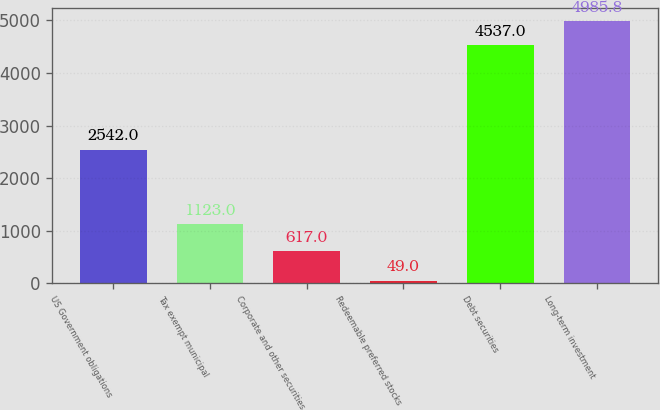Convert chart. <chart><loc_0><loc_0><loc_500><loc_500><bar_chart><fcel>US Government obligations<fcel>Tax exempt municipal<fcel>Corporate and other securities<fcel>Redeemable preferred stocks<fcel>Debt securities<fcel>Long-term investment<nl><fcel>2542<fcel>1123<fcel>617<fcel>49<fcel>4537<fcel>4985.8<nl></chart> 